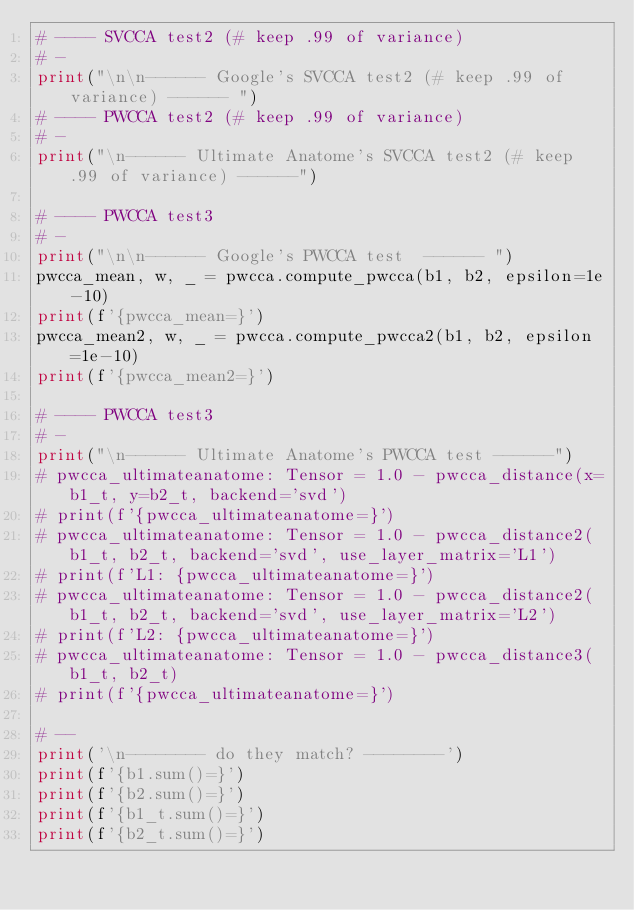<code> <loc_0><loc_0><loc_500><loc_500><_Python_># ---- SVCCA test2 (# keep .99 of variance)
# -
print("\n\n------ Google's SVCCA test2 (# keep .99 of variance) ------ ")
# ---- PWCCA test2 (# keep .99 of variance)
# -
print("\n------ Ultimate Anatome's SVCCA test2 (# keep .99 of variance) ------")

# ---- PWCCA test3
# -
print("\n\n------ Google's PWCCA test  ------ ")
pwcca_mean, w, _ = pwcca.compute_pwcca(b1, b2, epsilon=1e-10)
print(f'{pwcca_mean=}')
pwcca_mean2, w, _ = pwcca.compute_pwcca2(b1, b2, epsilon=1e-10)
print(f'{pwcca_mean2=}')

# ---- PWCCA test3
# -
print("\n------ Ultimate Anatome's PWCCA test ------")
# pwcca_ultimateanatome: Tensor = 1.0 - pwcca_distance(x=b1_t, y=b2_t, backend='svd')
# print(f'{pwcca_ultimateanatome=}')
# pwcca_ultimateanatome: Tensor = 1.0 - pwcca_distance2(b1_t, b2_t, backend='svd', use_layer_matrix='L1')
# print(f'L1: {pwcca_ultimateanatome=}')
# pwcca_ultimateanatome: Tensor = 1.0 - pwcca_distance2(b1_t, b2_t, backend='svd', use_layer_matrix='L2')
# print(f'L2: {pwcca_ultimateanatome=}')
# pwcca_ultimateanatome: Tensor = 1.0 - pwcca_distance3(b1_t, b2_t)
# print(f'{pwcca_ultimateanatome=}')

# --
print('\n-------- do they match? --------')
print(f'{b1.sum()=}')
print(f'{b2.sum()=}')
print(f'{b1_t.sum()=}')
print(f'{b2_t.sum()=}')</code> 